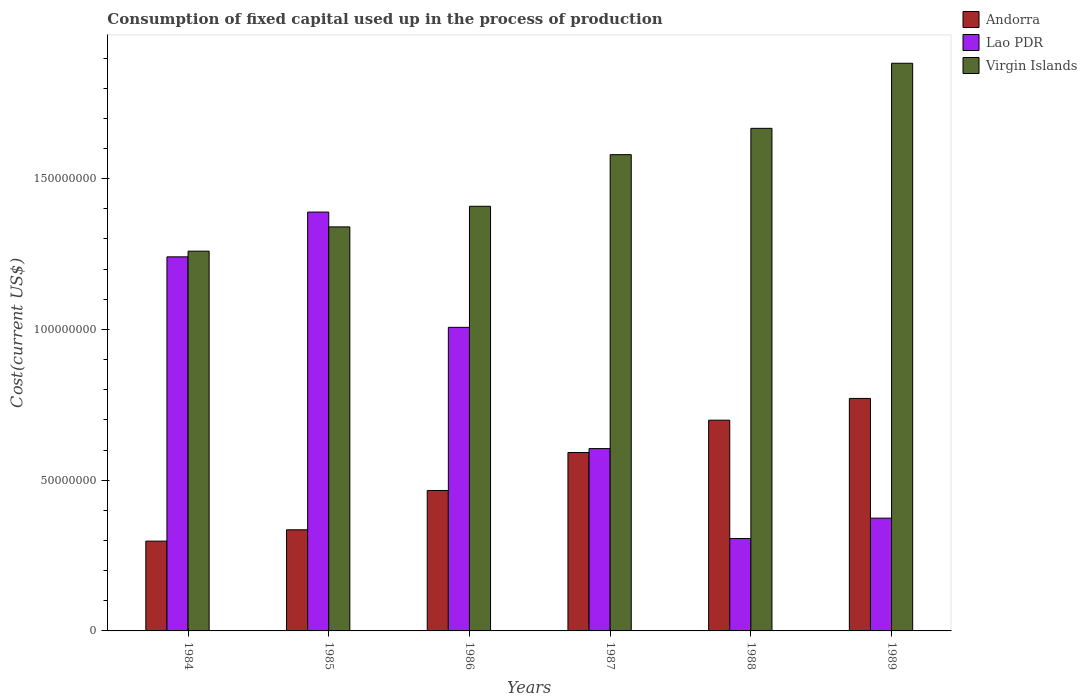Are the number of bars per tick equal to the number of legend labels?
Your answer should be very brief. Yes. What is the label of the 5th group of bars from the left?
Provide a short and direct response. 1988. What is the amount consumed in the process of production in Andorra in 1985?
Give a very brief answer. 3.35e+07. Across all years, what is the maximum amount consumed in the process of production in Andorra?
Keep it short and to the point. 7.71e+07. Across all years, what is the minimum amount consumed in the process of production in Virgin Islands?
Your response must be concise. 1.26e+08. What is the total amount consumed in the process of production in Andorra in the graph?
Give a very brief answer. 3.16e+08. What is the difference between the amount consumed in the process of production in Lao PDR in 1987 and that in 1989?
Offer a terse response. 2.31e+07. What is the difference between the amount consumed in the process of production in Lao PDR in 1985 and the amount consumed in the process of production in Andorra in 1984?
Your answer should be compact. 1.09e+08. What is the average amount consumed in the process of production in Andorra per year?
Keep it short and to the point. 5.27e+07. In the year 1986, what is the difference between the amount consumed in the process of production in Lao PDR and amount consumed in the process of production in Virgin Islands?
Ensure brevity in your answer.  -4.02e+07. In how many years, is the amount consumed in the process of production in Lao PDR greater than 150000000 US$?
Provide a succinct answer. 0. What is the ratio of the amount consumed in the process of production in Lao PDR in 1984 to that in 1987?
Make the answer very short. 2.05. Is the amount consumed in the process of production in Andorra in 1986 less than that in 1989?
Your answer should be compact. Yes. What is the difference between the highest and the second highest amount consumed in the process of production in Lao PDR?
Provide a short and direct response. 1.48e+07. What is the difference between the highest and the lowest amount consumed in the process of production in Andorra?
Your answer should be very brief. 4.73e+07. Is the sum of the amount consumed in the process of production in Lao PDR in 1985 and 1988 greater than the maximum amount consumed in the process of production in Andorra across all years?
Ensure brevity in your answer.  Yes. What does the 3rd bar from the left in 1988 represents?
Make the answer very short. Virgin Islands. What does the 1st bar from the right in 1989 represents?
Provide a short and direct response. Virgin Islands. Are all the bars in the graph horizontal?
Your answer should be compact. No. How many years are there in the graph?
Your answer should be compact. 6. What is the difference between two consecutive major ticks on the Y-axis?
Your response must be concise. 5.00e+07. Are the values on the major ticks of Y-axis written in scientific E-notation?
Make the answer very short. No. Does the graph contain any zero values?
Your answer should be compact. No. Does the graph contain grids?
Offer a very short reply. No. How many legend labels are there?
Keep it short and to the point. 3. What is the title of the graph?
Your response must be concise. Consumption of fixed capital used up in the process of production. What is the label or title of the Y-axis?
Ensure brevity in your answer.  Cost(current US$). What is the Cost(current US$) of Andorra in 1984?
Your answer should be compact. 2.98e+07. What is the Cost(current US$) of Lao PDR in 1984?
Provide a succinct answer. 1.24e+08. What is the Cost(current US$) in Virgin Islands in 1984?
Make the answer very short. 1.26e+08. What is the Cost(current US$) of Andorra in 1985?
Offer a very short reply. 3.35e+07. What is the Cost(current US$) in Lao PDR in 1985?
Provide a succinct answer. 1.39e+08. What is the Cost(current US$) in Virgin Islands in 1985?
Make the answer very short. 1.34e+08. What is the Cost(current US$) of Andorra in 1986?
Give a very brief answer. 4.66e+07. What is the Cost(current US$) in Lao PDR in 1986?
Ensure brevity in your answer.  1.01e+08. What is the Cost(current US$) of Virgin Islands in 1986?
Your answer should be compact. 1.41e+08. What is the Cost(current US$) in Andorra in 1987?
Ensure brevity in your answer.  5.92e+07. What is the Cost(current US$) in Lao PDR in 1987?
Make the answer very short. 6.05e+07. What is the Cost(current US$) in Virgin Islands in 1987?
Ensure brevity in your answer.  1.58e+08. What is the Cost(current US$) of Andorra in 1988?
Keep it short and to the point. 6.99e+07. What is the Cost(current US$) in Lao PDR in 1988?
Offer a very short reply. 3.06e+07. What is the Cost(current US$) of Virgin Islands in 1988?
Your answer should be very brief. 1.67e+08. What is the Cost(current US$) in Andorra in 1989?
Offer a terse response. 7.71e+07. What is the Cost(current US$) in Lao PDR in 1989?
Offer a very short reply. 3.74e+07. What is the Cost(current US$) of Virgin Islands in 1989?
Offer a very short reply. 1.88e+08. Across all years, what is the maximum Cost(current US$) of Andorra?
Your answer should be very brief. 7.71e+07. Across all years, what is the maximum Cost(current US$) of Lao PDR?
Offer a very short reply. 1.39e+08. Across all years, what is the maximum Cost(current US$) in Virgin Islands?
Give a very brief answer. 1.88e+08. Across all years, what is the minimum Cost(current US$) in Andorra?
Your answer should be compact. 2.98e+07. Across all years, what is the minimum Cost(current US$) of Lao PDR?
Provide a short and direct response. 3.06e+07. Across all years, what is the minimum Cost(current US$) in Virgin Islands?
Offer a terse response. 1.26e+08. What is the total Cost(current US$) of Andorra in the graph?
Keep it short and to the point. 3.16e+08. What is the total Cost(current US$) of Lao PDR in the graph?
Provide a short and direct response. 4.92e+08. What is the total Cost(current US$) in Virgin Islands in the graph?
Give a very brief answer. 9.14e+08. What is the difference between the Cost(current US$) in Andorra in 1984 and that in 1985?
Ensure brevity in your answer.  -3.76e+06. What is the difference between the Cost(current US$) of Lao PDR in 1984 and that in 1985?
Make the answer very short. -1.48e+07. What is the difference between the Cost(current US$) in Virgin Islands in 1984 and that in 1985?
Offer a very short reply. -8.05e+06. What is the difference between the Cost(current US$) in Andorra in 1984 and that in 1986?
Offer a very short reply. -1.68e+07. What is the difference between the Cost(current US$) of Lao PDR in 1984 and that in 1986?
Ensure brevity in your answer.  2.34e+07. What is the difference between the Cost(current US$) in Virgin Islands in 1984 and that in 1986?
Keep it short and to the point. -1.49e+07. What is the difference between the Cost(current US$) of Andorra in 1984 and that in 1987?
Provide a short and direct response. -2.94e+07. What is the difference between the Cost(current US$) of Lao PDR in 1984 and that in 1987?
Your answer should be very brief. 6.36e+07. What is the difference between the Cost(current US$) of Virgin Islands in 1984 and that in 1987?
Provide a short and direct response. -3.20e+07. What is the difference between the Cost(current US$) in Andorra in 1984 and that in 1988?
Offer a very short reply. -4.01e+07. What is the difference between the Cost(current US$) of Lao PDR in 1984 and that in 1988?
Offer a terse response. 9.34e+07. What is the difference between the Cost(current US$) in Virgin Islands in 1984 and that in 1988?
Ensure brevity in your answer.  -4.07e+07. What is the difference between the Cost(current US$) of Andorra in 1984 and that in 1989?
Your answer should be compact. -4.73e+07. What is the difference between the Cost(current US$) in Lao PDR in 1984 and that in 1989?
Your response must be concise. 8.67e+07. What is the difference between the Cost(current US$) in Virgin Islands in 1984 and that in 1989?
Make the answer very short. -6.23e+07. What is the difference between the Cost(current US$) of Andorra in 1985 and that in 1986?
Ensure brevity in your answer.  -1.30e+07. What is the difference between the Cost(current US$) in Lao PDR in 1985 and that in 1986?
Your answer should be very brief. 3.82e+07. What is the difference between the Cost(current US$) of Virgin Islands in 1985 and that in 1986?
Offer a very short reply. -6.84e+06. What is the difference between the Cost(current US$) of Andorra in 1985 and that in 1987?
Give a very brief answer. -2.56e+07. What is the difference between the Cost(current US$) in Lao PDR in 1985 and that in 1987?
Your answer should be compact. 7.84e+07. What is the difference between the Cost(current US$) of Virgin Islands in 1985 and that in 1987?
Provide a succinct answer. -2.40e+07. What is the difference between the Cost(current US$) in Andorra in 1985 and that in 1988?
Give a very brief answer. -3.64e+07. What is the difference between the Cost(current US$) in Lao PDR in 1985 and that in 1988?
Your answer should be very brief. 1.08e+08. What is the difference between the Cost(current US$) of Virgin Islands in 1985 and that in 1988?
Make the answer very short. -3.27e+07. What is the difference between the Cost(current US$) of Andorra in 1985 and that in 1989?
Provide a succinct answer. -4.36e+07. What is the difference between the Cost(current US$) in Lao PDR in 1985 and that in 1989?
Keep it short and to the point. 1.02e+08. What is the difference between the Cost(current US$) in Virgin Islands in 1985 and that in 1989?
Ensure brevity in your answer.  -5.43e+07. What is the difference between the Cost(current US$) in Andorra in 1986 and that in 1987?
Provide a succinct answer. -1.26e+07. What is the difference between the Cost(current US$) of Lao PDR in 1986 and that in 1987?
Ensure brevity in your answer.  4.02e+07. What is the difference between the Cost(current US$) of Virgin Islands in 1986 and that in 1987?
Your answer should be very brief. -1.71e+07. What is the difference between the Cost(current US$) of Andorra in 1986 and that in 1988?
Keep it short and to the point. -2.33e+07. What is the difference between the Cost(current US$) of Lao PDR in 1986 and that in 1988?
Provide a short and direct response. 7.00e+07. What is the difference between the Cost(current US$) of Virgin Islands in 1986 and that in 1988?
Keep it short and to the point. -2.58e+07. What is the difference between the Cost(current US$) of Andorra in 1986 and that in 1989?
Provide a succinct answer. -3.05e+07. What is the difference between the Cost(current US$) in Lao PDR in 1986 and that in 1989?
Your answer should be compact. 6.33e+07. What is the difference between the Cost(current US$) of Virgin Islands in 1986 and that in 1989?
Provide a succinct answer. -4.74e+07. What is the difference between the Cost(current US$) of Andorra in 1987 and that in 1988?
Keep it short and to the point. -1.07e+07. What is the difference between the Cost(current US$) of Lao PDR in 1987 and that in 1988?
Your answer should be compact. 2.98e+07. What is the difference between the Cost(current US$) in Virgin Islands in 1987 and that in 1988?
Your answer should be very brief. -8.73e+06. What is the difference between the Cost(current US$) of Andorra in 1987 and that in 1989?
Keep it short and to the point. -1.79e+07. What is the difference between the Cost(current US$) of Lao PDR in 1987 and that in 1989?
Provide a short and direct response. 2.31e+07. What is the difference between the Cost(current US$) of Virgin Islands in 1987 and that in 1989?
Your response must be concise. -3.03e+07. What is the difference between the Cost(current US$) in Andorra in 1988 and that in 1989?
Your response must be concise. -7.22e+06. What is the difference between the Cost(current US$) in Lao PDR in 1988 and that in 1989?
Make the answer very short. -6.76e+06. What is the difference between the Cost(current US$) of Virgin Islands in 1988 and that in 1989?
Ensure brevity in your answer.  -2.16e+07. What is the difference between the Cost(current US$) in Andorra in 1984 and the Cost(current US$) in Lao PDR in 1985?
Offer a terse response. -1.09e+08. What is the difference between the Cost(current US$) in Andorra in 1984 and the Cost(current US$) in Virgin Islands in 1985?
Offer a terse response. -1.04e+08. What is the difference between the Cost(current US$) of Lao PDR in 1984 and the Cost(current US$) of Virgin Islands in 1985?
Offer a terse response. -9.93e+06. What is the difference between the Cost(current US$) in Andorra in 1984 and the Cost(current US$) in Lao PDR in 1986?
Your response must be concise. -7.09e+07. What is the difference between the Cost(current US$) of Andorra in 1984 and the Cost(current US$) of Virgin Islands in 1986?
Offer a terse response. -1.11e+08. What is the difference between the Cost(current US$) of Lao PDR in 1984 and the Cost(current US$) of Virgin Islands in 1986?
Provide a short and direct response. -1.68e+07. What is the difference between the Cost(current US$) in Andorra in 1984 and the Cost(current US$) in Lao PDR in 1987?
Give a very brief answer. -3.07e+07. What is the difference between the Cost(current US$) of Andorra in 1984 and the Cost(current US$) of Virgin Islands in 1987?
Make the answer very short. -1.28e+08. What is the difference between the Cost(current US$) in Lao PDR in 1984 and the Cost(current US$) in Virgin Islands in 1987?
Your answer should be compact. -3.39e+07. What is the difference between the Cost(current US$) in Andorra in 1984 and the Cost(current US$) in Lao PDR in 1988?
Provide a short and direct response. -8.60e+05. What is the difference between the Cost(current US$) of Andorra in 1984 and the Cost(current US$) of Virgin Islands in 1988?
Offer a terse response. -1.37e+08. What is the difference between the Cost(current US$) in Lao PDR in 1984 and the Cost(current US$) in Virgin Islands in 1988?
Offer a terse response. -4.26e+07. What is the difference between the Cost(current US$) of Andorra in 1984 and the Cost(current US$) of Lao PDR in 1989?
Give a very brief answer. -7.62e+06. What is the difference between the Cost(current US$) of Andorra in 1984 and the Cost(current US$) of Virgin Islands in 1989?
Your answer should be compact. -1.58e+08. What is the difference between the Cost(current US$) in Lao PDR in 1984 and the Cost(current US$) in Virgin Islands in 1989?
Offer a terse response. -6.42e+07. What is the difference between the Cost(current US$) of Andorra in 1985 and the Cost(current US$) of Lao PDR in 1986?
Offer a terse response. -6.71e+07. What is the difference between the Cost(current US$) of Andorra in 1985 and the Cost(current US$) of Virgin Islands in 1986?
Offer a very short reply. -1.07e+08. What is the difference between the Cost(current US$) in Lao PDR in 1985 and the Cost(current US$) in Virgin Islands in 1986?
Provide a succinct answer. -1.93e+06. What is the difference between the Cost(current US$) of Andorra in 1985 and the Cost(current US$) of Lao PDR in 1987?
Offer a terse response. -2.69e+07. What is the difference between the Cost(current US$) of Andorra in 1985 and the Cost(current US$) of Virgin Islands in 1987?
Provide a short and direct response. -1.24e+08. What is the difference between the Cost(current US$) of Lao PDR in 1985 and the Cost(current US$) of Virgin Islands in 1987?
Give a very brief answer. -1.90e+07. What is the difference between the Cost(current US$) of Andorra in 1985 and the Cost(current US$) of Lao PDR in 1988?
Offer a terse response. 2.90e+06. What is the difference between the Cost(current US$) in Andorra in 1985 and the Cost(current US$) in Virgin Islands in 1988?
Ensure brevity in your answer.  -1.33e+08. What is the difference between the Cost(current US$) in Lao PDR in 1985 and the Cost(current US$) in Virgin Islands in 1988?
Offer a very short reply. -2.78e+07. What is the difference between the Cost(current US$) in Andorra in 1985 and the Cost(current US$) in Lao PDR in 1989?
Provide a short and direct response. -3.86e+06. What is the difference between the Cost(current US$) of Andorra in 1985 and the Cost(current US$) of Virgin Islands in 1989?
Ensure brevity in your answer.  -1.55e+08. What is the difference between the Cost(current US$) in Lao PDR in 1985 and the Cost(current US$) in Virgin Islands in 1989?
Provide a short and direct response. -4.94e+07. What is the difference between the Cost(current US$) in Andorra in 1986 and the Cost(current US$) in Lao PDR in 1987?
Your answer should be compact. -1.39e+07. What is the difference between the Cost(current US$) of Andorra in 1986 and the Cost(current US$) of Virgin Islands in 1987?
Provide a short and direct response. -1.11e+08. What is the difference between the Cost(current US$) in Lao PDR in 1986 and the Cost(current US$) in Virgin Islands in 1987?
Give a very brief answer. -5.73e+07. What is the difference between the Cost(current US$) in Andorra in 1986 and the Cost(current US$) in Lao PDR in 1988?
Your answer should be compact. 1.59e+07. What is the difference between the Cost(current US$) in Andorra in 1986 and the Cost(current US$) in Virgin Islands in 1988?
Your response must be concise. -1.20e+08. What is the difference between the Cost(current US$) in Lao PDR in 1986 and the Cost(current US$) in Virgin Islands in 1988?
Your response must be concise. -6.60e+07. What is the difference between the Cost(current US$) of Andorra in 1986 and the Cost(current US$) of Lao PDR in 1989?
Make the answer very short. 9.17e+06. What is the difference between the Cost(current US$) in Andorra in 1986 and the Cost(current US$) in Virgin Islands in 1989?
Your answer should be very brief. -1.42e+08. What is the difference between the Cost(current US$) of Lao PDR in 1986 and the Cost(current US$) of Virgin Islands in 1989?
Make the answer very short. -8.76e+07. What is the difference between the Cost(current US$) of Andorra in 1987 and the Cost(current US$) of Lao PDR in 1988?
Ensure brevity in your answer.  2.85e+07. What is the difference between the Cost(current US$) in Andorra in 1987 and the Cost(current US$) in Virgin Islands in 1988?
Your answer should be very brief. -1.08e+08. What is the difference between the Cost(current US$) in Lao PDR in 1987 and the Cost(current US$) in Virgin Islands in 1988?
Make the answer very short. -1.06e+08. What is the difference between the Cost(current US$) of Andorra in 1987 and the Cost(current US$) of Lao PDR in 1989?
Give a very brief answer. 2.18e+07. What is the difference between the Cost(current US$) in Andorra in 1987 and the Cost(current US$) in Virgin Islands in 1989?
Your answer should be compact. -1.29e+08. What is the difference between the Cost(current US$) in Lao PDR in 1987 and the Cost(current US$) in Virgin Islands in 1989?
Provide a succinct answer. -1.28e+08. What is the difference between the Cost(current US$) of Andorra in 1988 and the Cost(current US$) of Lao PDR in 1989?
Give a very brief answer. 3.25e+07. What is the difference between the Cost(current US$) in Andorra in 1988 and the Cost(current US$) in Virgin Islands in 1989?
Offer a very short reply. -1.18e+08. What is the difference between the Cost(current US$) of Lao PDR in 1988 and the Cost(current US$) of Virgin Islands in 1989?
Provide a short and direct response. -1.58e+08. What is the average Cost(current US$) in Andorra per year?
Your answer should be compact. 5.27e+07. What is the average Cost(current US$) in Lao PDR per year?
Your response must be concise. 8.20e+07. What is the average Cost(current US$) in Virgin Islands per year?
Keep it short and to the point. 1.52e+08. In the year 1984, what is the difference between the Cost(current US$) of Andorra and Cost(current US$) of Lao PDR?
Provide a succinct answer. -9.43e+07. In the year 1984, what is the difference between the Cost(current US$) of Andorra and Cost(current US$) of Virgin Islands?
Make the answer very short. -9.62e+07. In the year 1984, what is the difference between the Cost(current US$) in Lao PDR and Cost(current US$) in Virgin Islands?
Provide a short and direct response. -1.88e+06. In the year 1985, what is the difference between the Cost(current US$) of Andorra and Cost(current US$) of Lao PDR?
Offer a terse response. -1.05e+08. In the year 1985, what is the difference between the Cost(current US$) of Andorra and Cost(current US$) of Virgin Islands?
Provide a succinct answer. -1.00e+08. In the year 1985, what is the difference between the Cost(current US$) in Lao PDR and Cost(current US$) in Virgin Islands?
Provide a succinct answer. 4.92e+06. In the year 1986, what is the difference between the Cost(current US$) of Andorra and Cost(current US$) of Lao PDR?
Provide a succinct answer. -5.41e+07. In the year 1986, what is the difference between the Cost(current US$) in Andorra and Cost(current US$) in Virgin Islands?
Keep it short and to the point. -9.43e+07. In the year 1986, what is the difference between the Cost(current US$) of Lao PDR and Cost(current US$) of Virgin Islands?
Provide a succinct answer. -4.02e+07. In the year 1987, what is the difference between the Cost(current US$) of Andorra and Cost(current US$) of Lao PDR?
Offer a very short reply. -1.31e+06. In the year 1987, what is the difference between the Cost(current US$) in Andorra and Cost(current US$) in Virgin Islands?
Provide a short and direct response. -9.88e+07. In the year 1987, what is the difference between the Cost(current US$) of Lao PDR and Cost(current US$) of Virgin Islands?
Offer a very short reply. -9.75e+07. In the year 1988, what is the difference between the Cost(current US$) in Andorra and Cost(current US$) in Lao PDR?
Your response must be concise. 3.93e+07. In the year 1988, what is the difference between the Cost(current US$) in Andorra and Cost(current US$) in Virgin Islands?
Your answer should be compact. -9.68e+07. In the year 1988, what is the difference between the Cost(current US$) in Lao PDR and Cost(current US$) in Virgin Islands?
Provide a succinct answer. -1.36e+08. In the year 1989, what is the difference between the Cost(current US$) of Andorra and Cost(current US$) of Lao PDR?
Keep it short and to the point. 3.97e+07. In the year 1989, what is the difference between the Cost(current US$) in Andorra and Cost(current US$) in Virgin Islands?
Provide a succinct answer. -1.11e+08. In the year 1989, what is the difference between the Cost(current US$) of Lao PDR and Cost(current US$) of Virgin Islands?
Keep it short and to the point. -1.51e+08. What is the ratio of the Cost(current US$) of Andorra in 1984 to that in 1985?
Give a very brief answer. 0.89. What is the ratio of the Cost(current US$) in Lao PDR in 1984 to that in 1985?
Offer a very short reply. 0.89. What is the ratio of the Cost(current US$) in Virgin Islands in 1984 to that in 1985?
Your response must be concise. 0.94. What is the ratio of the Cost(current US$) of Andorra in 1984 to that in 1986?
Offer a very short reply. 0.64. What is the ratio of the Cost(current US$) of Lao PDR in 1984 to that in 1986?
Your answer should be compact. 1.23. What is the ratio of the Cost(current US$) in Virgin Islands in 1984 to that in 1986?
Provide a succinct answer. 0.89. What is the ratio of the Cost(current US$) of Andorra in 1984 to that in 1987?
Offer a terse response. 0.5. What is the ratio of the Cost(current US$) in Lao PDR in 1984 to that in 1987?
Provide a short and direct response. 2.05. What is the ratio of the Cost(current US$) in Virgin Islands in 1984 to that in 1987?
Give a very brief answer. 0.8. What is the ratio of the Cost(current US$) in Andorra in 1984 to that in 1988?
Your answer should be very brief. 0.43. What is the ratio of the Cost(current US$) in Lao PDR in 1984 to that in 1988?
Offer a very short reply. 4.05. What is the ratio of the Cost(current US$) of Virgin Islands in 1984 to that in 1988?
Ensure brevity in your answer.  0.76. What is the ratio of the Cost(current US$) in Andorra in 1984 to that in 1989?
Provide a short and direct response. 0.39. What is the ratio of the Cost(current US$) in Lao PDR in 1984 to that in 1989?
Your answer should be very brief. 3.32. What is the ratio of the Cost(current US$) in Virgin Islands in 1984 to that in 1989?
Your answer should be compact. 0.67. What is the ratio of the Cost(current US$) in Andorra in 1985 to that in 1986?
Provide a short and direct response. 0.72. What is the ratio of the Cost(current US$) in Lao PDR in 1985 to that in 1986?
Offer a very short reply. 1.38. What is the ratio of the Cost(current US$) of Virgin Islands in 1985 to that in 1986?
Provide a succinct answer. 0.95. What is the ratio of the Cost(current US$) in Andorra in 1985 to that in 1987?
Your answer should be compact. 0.57. What is the ratio of the Cost(current US$) in Lao PDR in 1985 to that in 1987?
Offer a very short reply. 2.3. What is the ratio of the Cost(current US$) of Virgin Islands in 1985 to that in 1987?
Ensure brevity in your answer.  0.85. What is the ratio of the Cost(current US$) in Andorra in 1985 to that in 1988?
Make the answer very short. 0.48. What is the ratio of the Cost(current US$) in Lao PDR in 1985 to that in 1988?
Your answer should be very brief. 4.53. What is the ratio of the Cost(current US$) in Virgin Islands in 1985 to that in 1988?
Offer a very short reply. 0.8. What is the ratio of the Cost(current US$) of Andorra in 1985 to that in 1989?
Ensure brevity in your answer.  0.43. What is the ratio of the Cost(current US$) in Lao PDR in 1985 to that in 1989?
Provide a short and direct response. 3.71. What is the ratio of the Cost(current US$) in Virgin Islands in 1985 to that in 1989?
Give a very brief answer. 0.71. What is the ratio of the Cost(current US$) in Andorra in 1986 to that in 1987?
Make the answer very short. 0.79. What is the ratio of the Cost(current US$) of Lao PDR in 1986 to that in 1987?
Offer a very short reply. 1.66. What is the ratio of the Cost(current US$) of Virgin Islands in 1986 to that in 1987?
Make the answer very short. 0.89. What is the ratio of the Cost(current US$) of Andorra in 1986 to that in 1988?
Offer a terse response. 0.67. What is the ratio of the Cost(current US$) of Lao PDR in 1986 to that in 1988?
Make the answer very short. 3.29. What is the ratio of the Cost(current US$) in Virgin Islands in 1986 to that in 1988?
Make the answer very short. 0.84. What is the ratio of the Cost(current US$) of Andorra in 1986 to that in 1989?
Offer a terse response. 0.6. What is the ratio of the Cost(current US$) in Lao PDR in 1986 to that in 1989?
Keep it short and to the point. 2.69. What is the ratio of the Cost(current US$) in Virgin Islands in 1986 to that in 1989?
Provide a succinct answer. 0.75. What is the ratio of the Cost(current US$) of Andorra in 1987 to that in 1988?
Ensure brevity in your answer.  0.85. What is the ratio of the Cost(current US$) in Lao PDR in 1987 to that in 1988?
Provide a short and direct response. 1.97. What is the ratio of the Cost(current US$) in Virgin Islands in 1987 to that in 1988?
Make the answer very short. 0.95. What is the ratio of the Cost(current US$) of Andorra in 1987 to that in 1989?
Provide a succinct answer. 0.77. What is the ratio of the Cost(current US$) of Lao PDR in 1987 to that in 1989?
Keep it short and to the point. 1.62. What is the ratio of the Cost(current US$) of Virgin Islands in 1987 to that in 1989?
Your answer should be compact. 0.84. What is the ratio of the Cost(current US$) of Andorra in 1988 to that in 1989?
Offer a terse response. 0.91. What is the ratio of the Cost(current US$) of Lao PDR in 1988 to that in 1989?
Provide a short and direct response. 0.82. What is the ratio of the Cost(current US$) of Virgin Islands in 1988 to that in 1989?
Ensure brevity in your answer.  0.89. What is the difference between the highest and the second highest Cost(current US$) of Andorra?
Keep it short and to the point. 7.22e+06. What is the difference between the highest and the second highest Cost(current US$) in Lao PDR?
Your response must be concise. 1.48e+07. What is the difference between the highest and the second highest Cost(current US$) in Virgin Islands?
Provide a succinct answer. 2.16e+07. What is the difference between the highest and the lowest Cost(current US$) in Andorra?
Your answer should be compact. 4.73e+07. What is the difference between the highest and the lowest Cost(current US$) in Lao PDR?
Your response must be concise. 1.08e+08. What is the difference between the highest and the lowest Cost(current US$) in Virgin Islands?
Provide a short and direct response. 6.23e+07. 